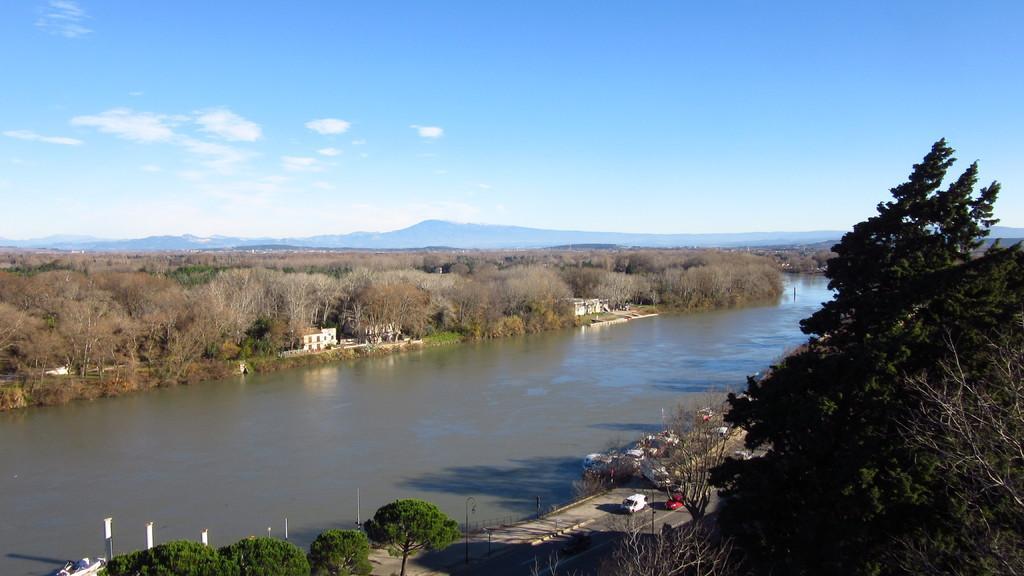Describe this image in one or two sentences. In this picture there is mountain river in the center of the image and there are cars on the road at the bottom side of the image and there are few houses in the image and there are trees in the image. 